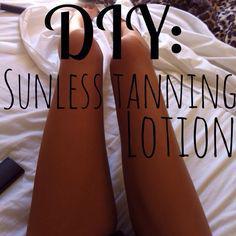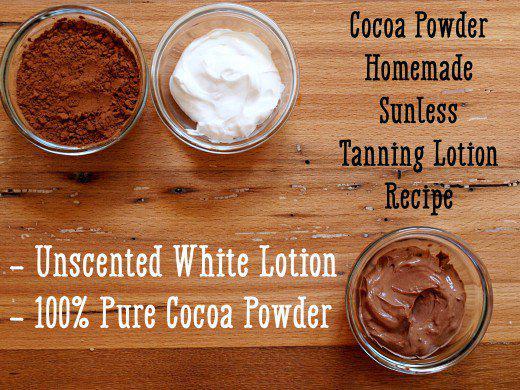The first image is the image on the left, the second image is the image on the right. Given the left and right images, does the statement "An image includes multiple clear containers filled with white and brown substances." hold true? Answer yes or no. Yes. The first image is the image on the left, the second image is the image on the right. Considering the images on both sides, is "Powder sits in a glass bowl in one of the images." valid? Answer yes or no. Yes. 